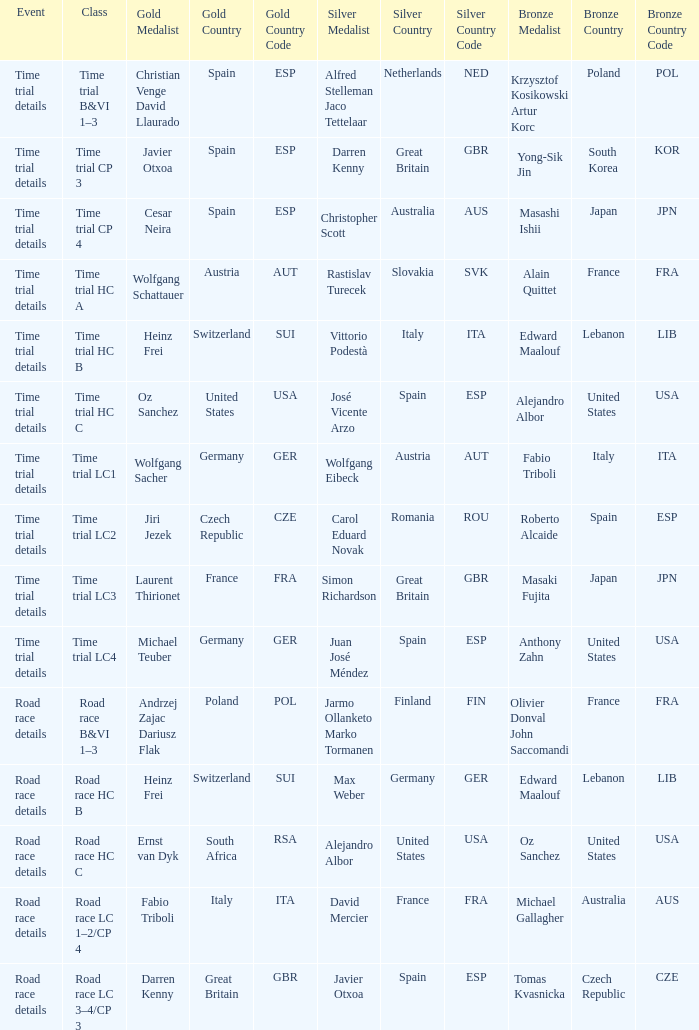Who garnered the gold prize during the time trial specifics when simon richardson of great britain (gbr) managed to win silver? Laurent Thirionet France (FRA). 